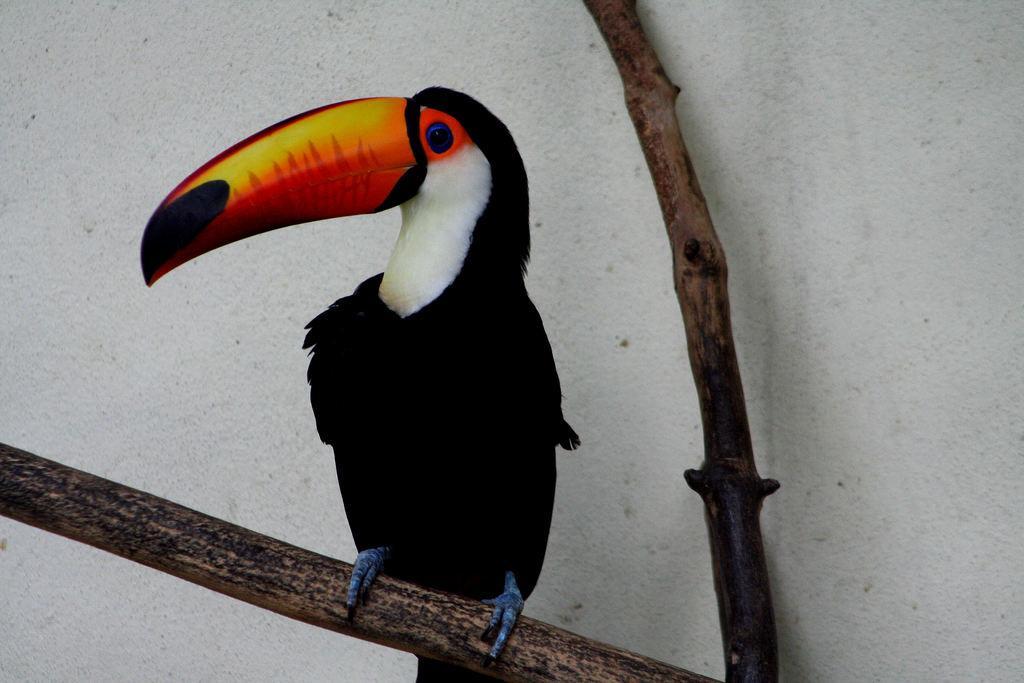Describe this image in one or two sentences. In this image in the center there is a bird standing on a branch of a tree. 